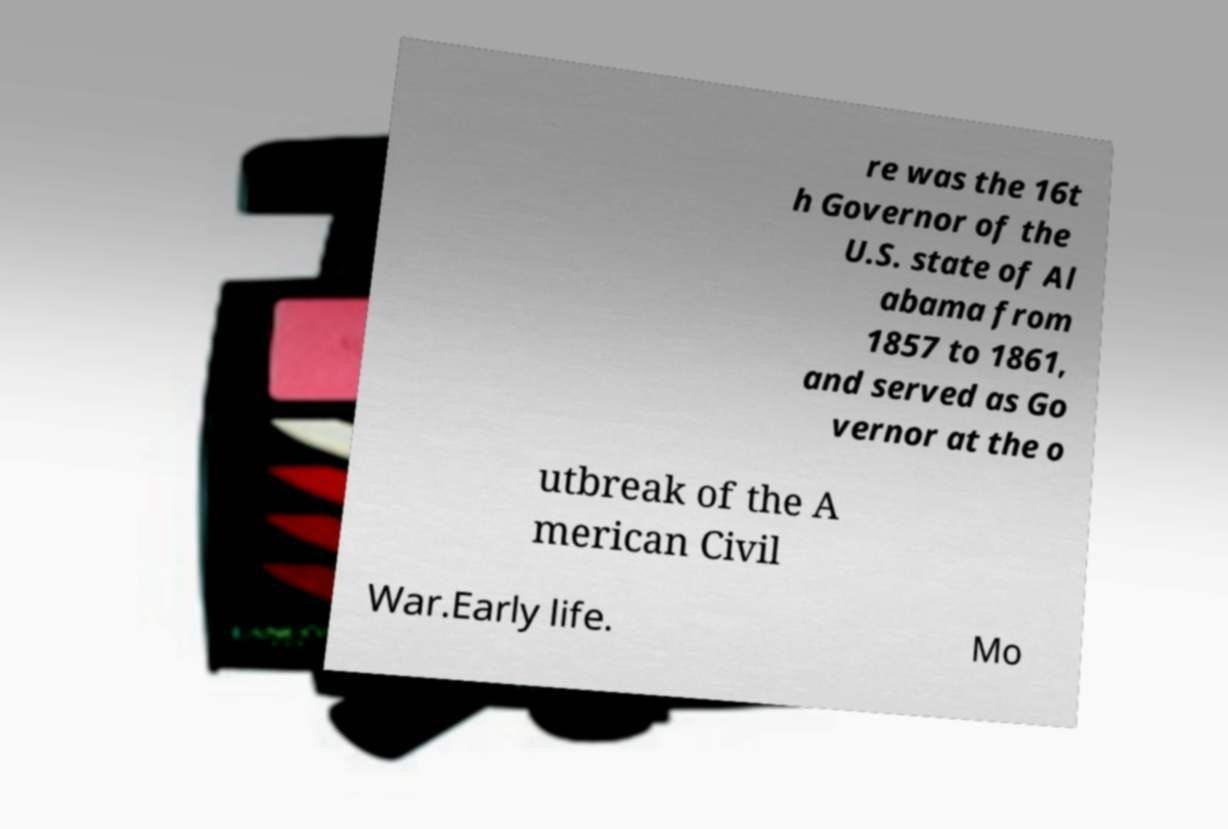What messages or text are displayed in this image? I need them in a readable, typed format. re was the 16t h Governor of the U.S. state of Al abama from 1857 to 1861, and served as Go vernor at the o utbreak of the A merican Civil War.Early life. Mo 